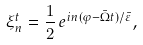<formula> <loc_0><loc_0><loc_500><loc_500>\xi ^ { t } _ { n } = \frac { 1 } { 2 } \, e ^ { i n ( \varphi - { \bar { \Omega } } t ) / { \bar { \varepsilon } } } ,</formula> 